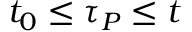<formula> <loc_0><loc_0><loc_500><loc_500>t _ { 0 } \leq \tau _ { P } \leq t</formula> 